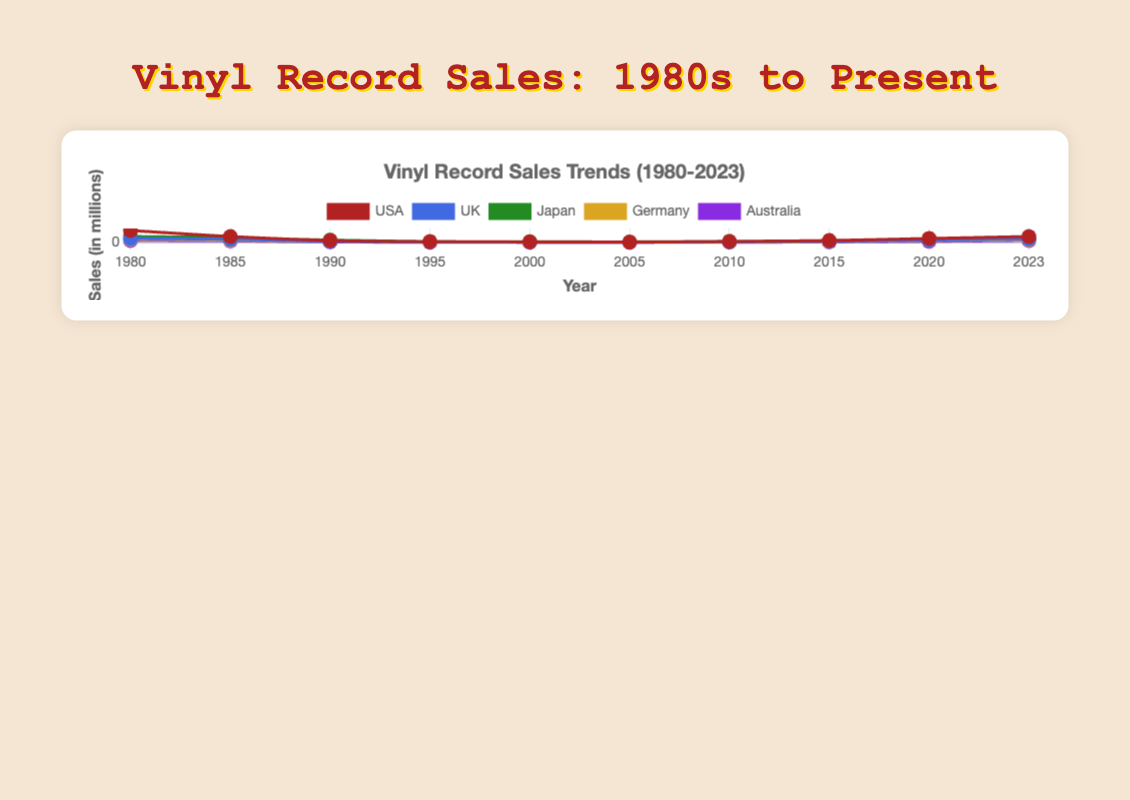What is the general trend in vinyl record sales in the USA from 1980 to 2023? From 1980 to 2005, there is a significant decline in sales, dropping from 300 million to 10 million. From 2005 onwards, sales gradually increase, reaching 150 million by 2023.
Answer: Decline, then increase Which country shows the most stable trend in vinyl record sales from 1980 to 2023? Japan shows the most stable trend without drastic peaks or troughs compared to other countries, starting at 150 million, slightly decreasing, and then relatively steady increases.
Answer: Japan In which year did the UK have the least vinyl record sales? The lowest sales for the UK are observed in 2005, as depicted at the lowest point on the line graph for the UK.
Answer: 2005 Between 2000 and 2020, in which year does Australia have the greatest increase in sales of vinyl records? The line graph for Australia shows a spike between 2015 and 2020, rising from 12 million to 30 million, indicating the greatest increase in 2020.
Answer: 2020 How does the vinyl record sales trend in Germany compare between 1980 and 2005? Starting from 1980 at 80 million, Germany's sales consistently decline to 4 million in 2005.
Answer: Consistent decline What is the combined vinyl record sales for all countries in 2000? The sales in 2000 for each country are USA: 15, UK: 8, Japan: 20, Germany: 6, and Australia: 3. Summing these gives 15+8+20+6+3 = 52 million.
Answer: 52 million By how much did Japan's vinyl sales increase from 2005 to 2023? In 2005, Japan's sales were 15 million. By 2023, sales had risen to 120 million. Thus, the increase is 120 - 15 = 105 million.
Answer: 105 million Compare the vinyl record sales in the USA and UK in 2023. How much higher are the USA sales compared to the UK? In 2023, the USA sales are 150 million, while the UK sales are 90 million. The difference is 150 - 90 = 60 million.
Answer: 60 million Which country had the highest vinyl record sales in 2023? The USA had the highest vinyl record sales in 2023, reaching 150 million.
Answer: USA What is the visual difference between the 1980 and 2023 sales lines for all countries combined? In 1980, sales are high across all countries, especially the USA and Japan. By 2023, there's a resurgence in sales, with all countries showing moderate to high increases, most prominently the USA and Japan.
Answer: High in both years, with resurgence by 2023 